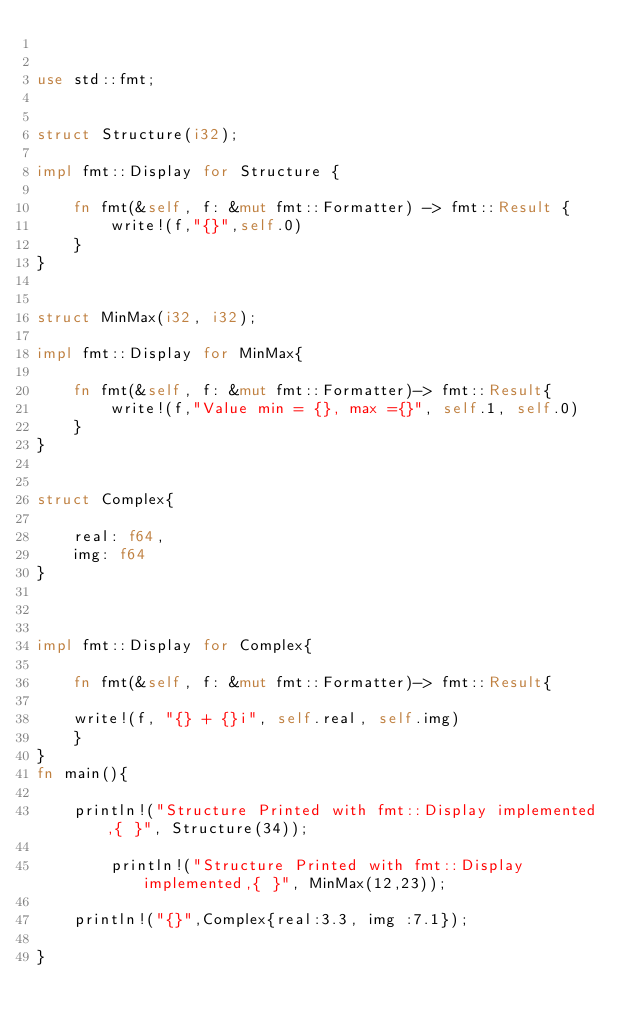Convert code to text. <code><loc_0><loc_0><loc_500><loc_500><_Rust_>

use std::fmt;


struct Structure(i32);

impl fmt::Display for Structure {

    fn fmt(&self, f: &mut fmt::Formatter) -> fmt::Result {
        write!(f,"{}",self.0)
    }
}


struct MinMax(i32, i32);

impl fmt::Display for MinMax{

    fn fmt(&self, f: &mut fmt::Formatter)-> fmt::Result{
        write!(f,"Value min = {}, max ={}", self.1, self.0)
    }
}


struct Complex{

    real: f64,
    img: f64
}



impl fmt::Display for Complex{

    fn fmt(&self, f: &mut fmt::Formatter)-> fmt::Result{

    write!(f, "{} + {}i", self.real, self.img)
    }
}
fn main(){
    
    println!("Structure Printed with fmt::Display implemented,{ }", Structure(34));

        println!("Structure Printed with fmt::Display implemented,{ }", MinMax(12,23));

    println!("{}",Complex{real:3.3, img :7.1});

}
</code> 